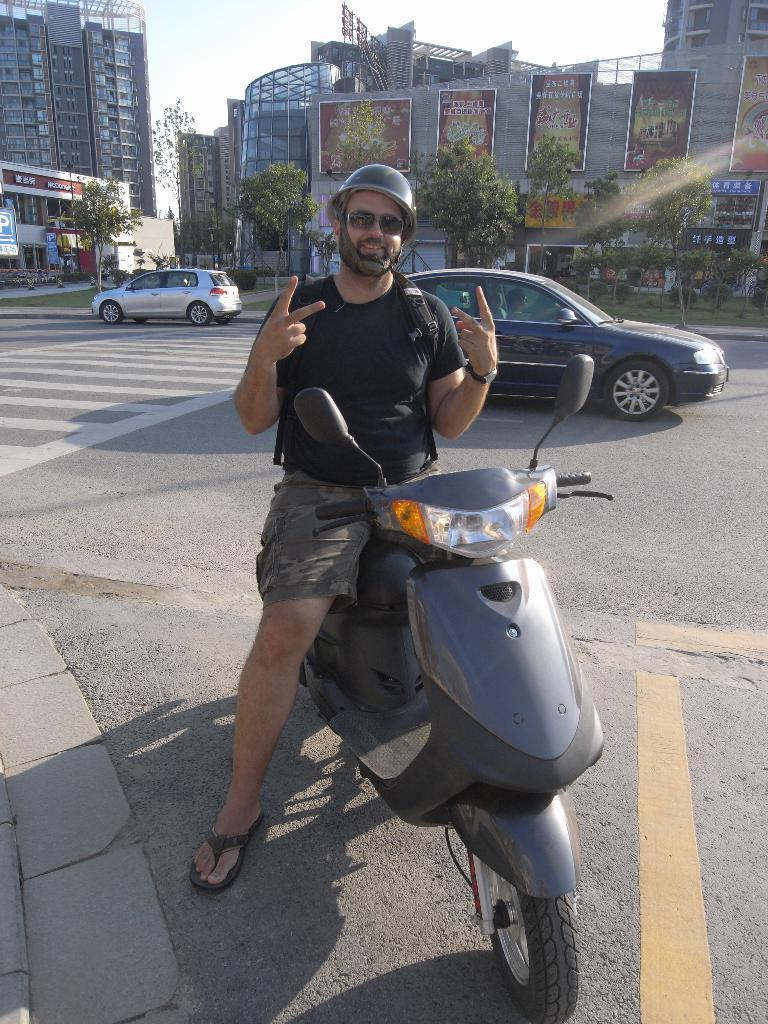What is the man in the image doing? The man is seated on a scooter in the image. What safety equipment is the man wearing? The man is wearing a helmet in the image. What type of eyewear is the man wearing? The man is wearing sunglasses in the image. What can be seen in the background of the image? There are trees, cars on the road, and buildings visible in the image. What is the weather like in the image? The sky is cloudy in the image. Can you tell me how many goldfish are swimming in the image? There are no goldfish present in the image. What type of monkey can be seen climbing the buildings in the image? There are no monkeys visible in the image; it features a man on a scooter with a cloudy sky in the background. 